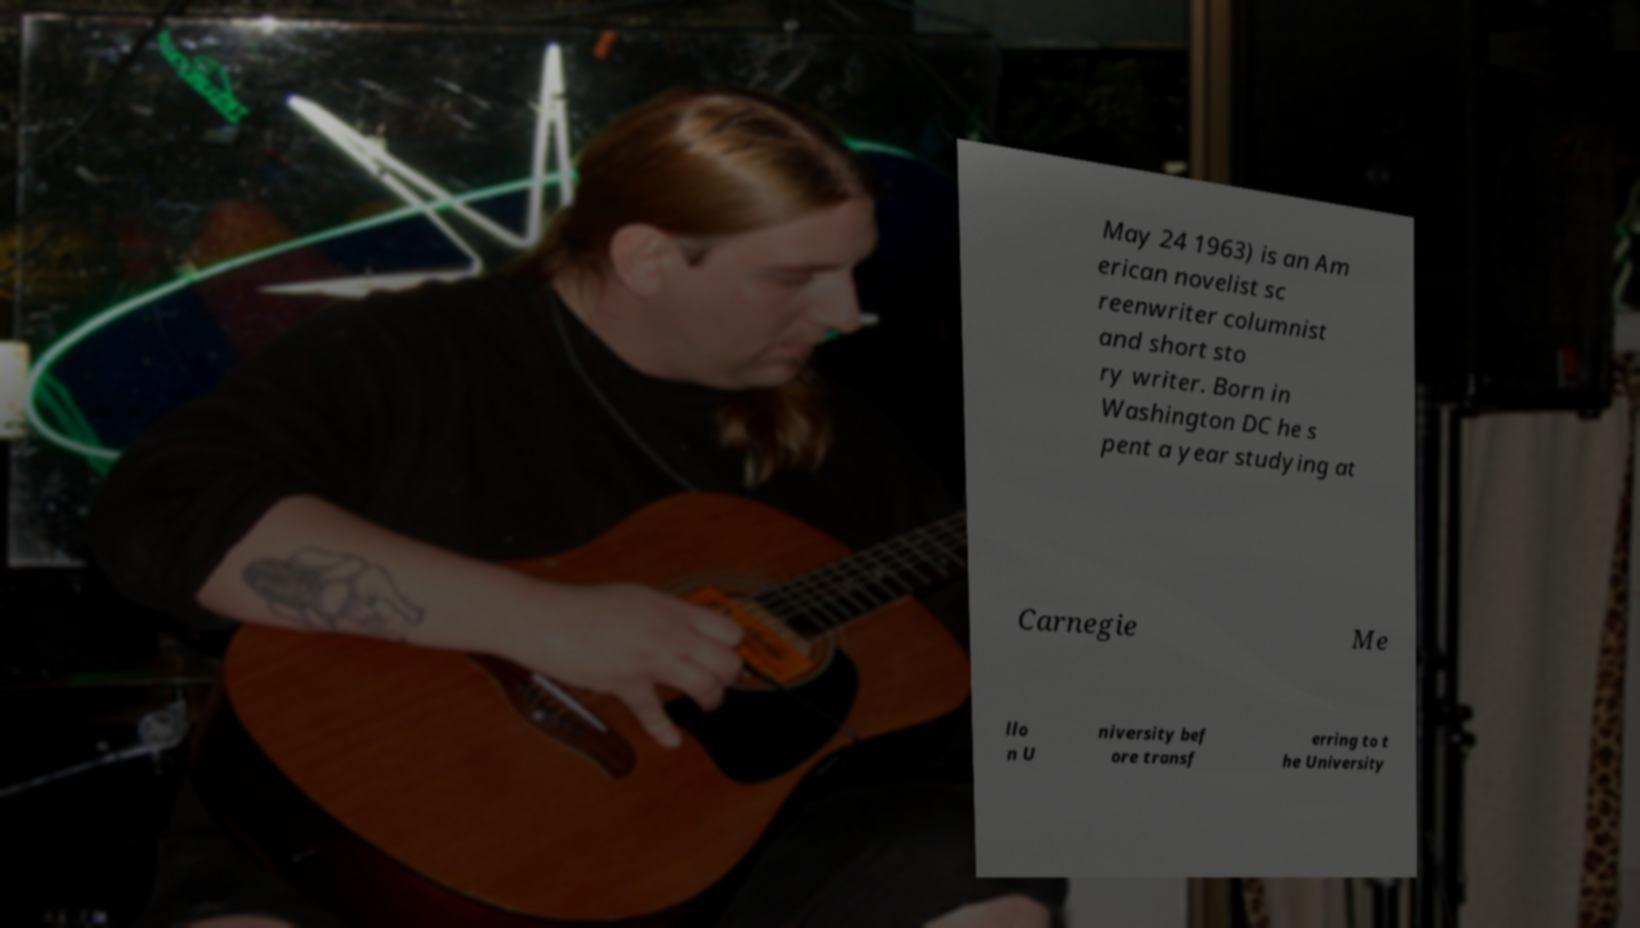Could you extract and type out the text from this image? May 24 1963) is an Am erican novelist sc reenwriter columnist and short sto ry writer. Born in Washington DC he s pent a year studying at Carnegie Me llo n U niversity bef ore transf erring to t he University 